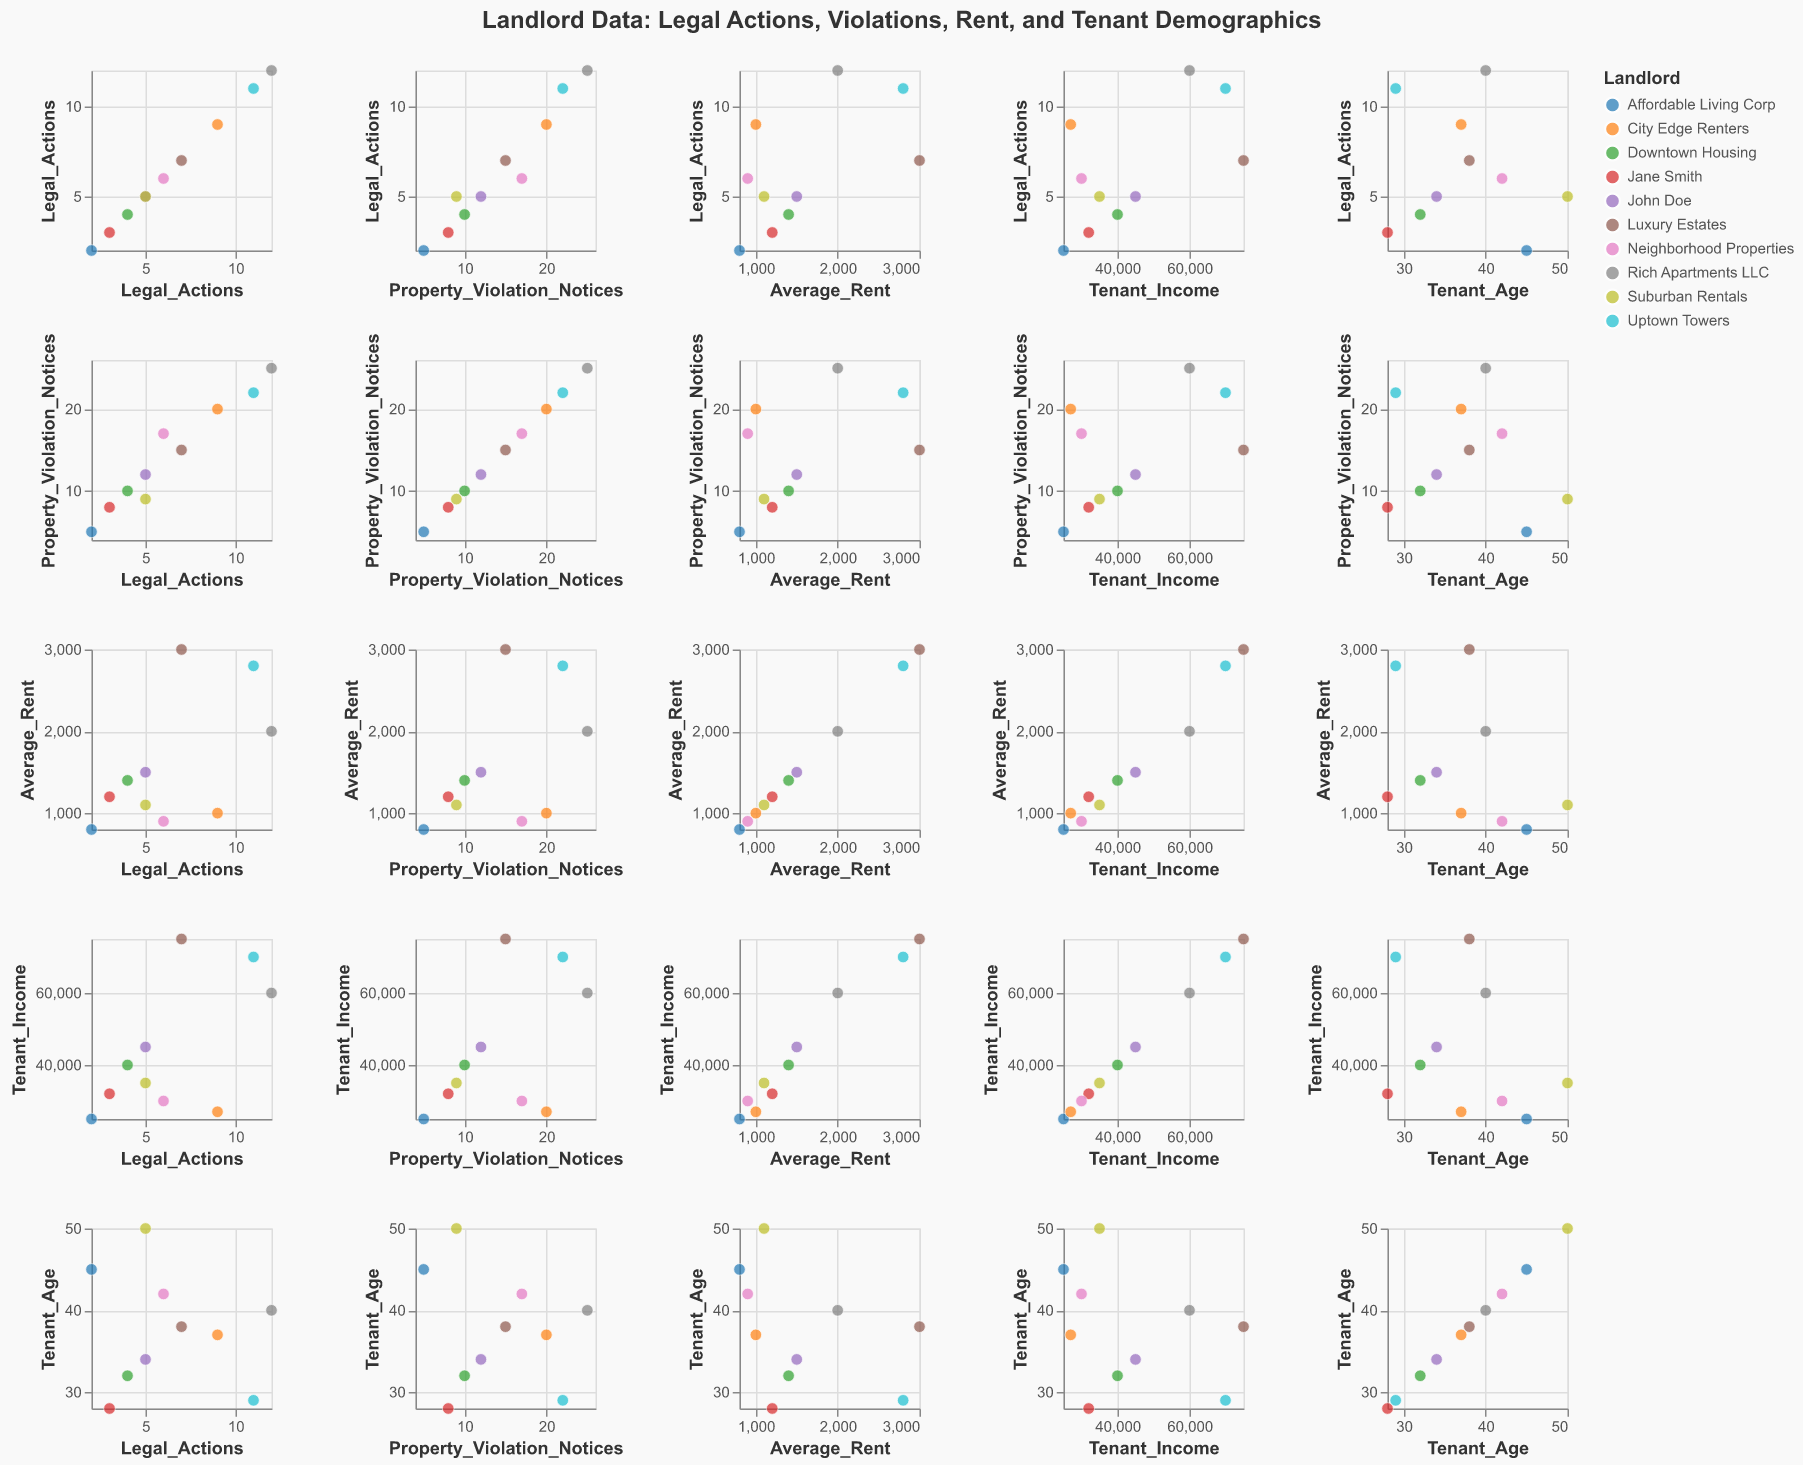What is the title of the figure? The title of the figure is typically displayed prominently at the top of the plot. In this case, it says "Landlord Data: Legal Actions, Violations, Rent, and Tenant Demographics."
Answer: "Landlord Data: Legal Actions, Violations, Rent, and Tenant Demographics" How many different landlords are represented in the data? By looking at the number of distinct colors in the scatter plot matrix legend (or by counting unique entities in the "Landlord" field), we can see that there are 10 different landlords represented.
Answer: 10 Which landlord has the highest number of legal actions? By examining the plot where "Legal_Actions" is on the y-axis, we observe that "Rich Apartments LLC" has the highest value, at 12.
Answer: "Rich Apartments LLC" Is there a correlation between Property Violation Notices and Legal Actions? Observing the scatter plot where "Property_Violation_Notices" is on one axis and "Legal_Actions" is on the other, we notice that as the number of Property Violation Notices increases, the number of Legal Actions tends to increase as well. This suggests a positive correlation.
Answer: Yes, there is a positive correlation Which landlord has tenants with the lowest average income? By inspecting the scatter plot where "Tenant_Income" is used, "Affordable Living Corp" tenants have the lowest average income at $25,000.
Answer: "Affordable Living Corp" How does Luxury Estates' average rent compare to other landlords? Examining the scatter plot where "Average_Rent" is one of the axes, Luxury Estates has one of the highest average rents at $3,000, with only "Uptown Towers" coming close at $2,800.
Answer: Luxury Estates has one of the highest average rents Are older tenants associated with higher or lower legal actions? By observing the scatter plots involving "Tenant_Age" and "Legal_Actions," no clear trend is apparent between tenant age and the number of legal actions, indicating no clear association.
Answer: No clear association Which landlord appears to target younger tenants? "Uptown Towers" has a lower average tenant age of 29, according to the scatter plots involving Tenant_Age.
Answer: "Uptown Towers" What is the difference between the highest and lowest Tenant Income? The highest Tenant Income is $75,000 (Luxury Estates), and the lowest is $25,000 (Affordable Living Corp). The difference is $75,000 - $25,000 = $50,000.
Answer: $50,000 Which landlord has the most property violation notices and what is the number? "Rich Apartments LLC" has the highest number of property violation notices, with a total of 25.
Answer: "Rich Apartments LLC" 